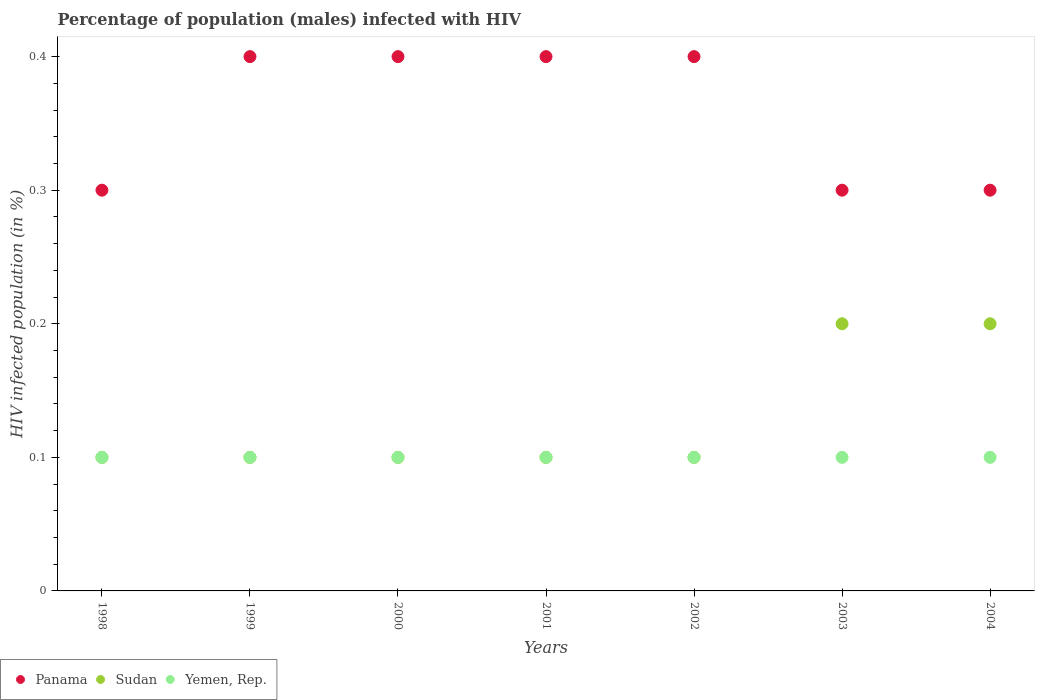How many different coloured dotlines are there?
Provide a short and direct response. 3. What is the percentage of HIV infected male population in Sudan in 2004?
Ensure brevity in your answer.  0.2. Across all years, what is the minimum percentage of HIV infected male population in Panama?
Give a very brief answer. 0.3. In which year was the percentage of HIV infected male population in Yemen, Rep. minimum?
Ensure brevity in your answer.  1998. What is the total percentage of HIV infected male population in Sudan in the graph?
Keep it short and to the point. 0.9. What is the difference between the percentage of HIV infected male population in Yemen, Rep. in 1998 and that in 2001?
Provide a succinct answer. 0. What is the difference between the percentage of HIV infected male population in Panama in 2004 and the percentage of HIV infected male population in Sudan in 1999?
Your answer should be very brief. 0.2. What is the average percentage of HIV infected male population in Yemen, Rep. per year?
Offer a terse response. 0.1. In the year 2003, what is the difference between the percentage of HIV infected male population in Panama and percentage of HIV infected male population in Yemen, Rep.?
Give a very brief answer. 0.2. What is the ratio of the percentage of HIV infected male population in Yemen, Rep. in 1998 to that in 2000?
Your response must be concise. 1. Is the difference between the percentage of HIV infected male population in Panama in 2001 and 2004 greater than the difference between the percentage of HIV infected male population in Yemen, Rep. in 2001 and 2004?
Keep it short and to the point. Yes. What is the difference between the highest and the lowest percentage of HIV infected male population in Yemen, Rep.?
Keep it short and to the point. 0. In how many years, is the percentage of HIV infected male population in Panama greater than the average percentage of HIV infected male population in Panama taken over all years?
Make the answer very short. 4. Is it the case that in every year, the sum of the percentage of HIV infected male population in Panama and percentage of HIV infected male population in Sudan  is greater than the percentage of HIV infected male population in Yemen, Rep.?
Make the answer very short. Yes. Does the percentage of HIV infected male population in Panama monotonically increase over the years?
Your answer should be compact. No. Is the percentage of HIV infected male population in Yemen, Rep. strictly greater than the percentage of HIV infected male population in Sudan over the years?
Your answer should be compact. No. Is the percentage of HIV infected male population in Yemen, Rep. strictly less than the percentage of HIV infected male population in Sudan over the years?
Provide a short and direct response. No. Does the graph contain any zero values?
Give a very brief answer. No. Does the graph contain grids?
Provide a short and direct response. No. Where does the legend appear in the graph?
Your answer should be compact. Bottom left. What is the title of the graph?
Ensure brevity in your answer.  Percentage of population (males) infected with HIV. What is the label or title of the X-axis?
Your answer should be very brief. Years. What is the label or title of the Y-axis?
Provide a short and direct response. HIV infected population (in %). What is the HIV infected population (in %) of Sudan in 1998?
Your answer should be compact. 0.1. What is the HIV infected population (in %) in Yemen, Rep. in 1998?
Your answer should be compact. 0.1. What is the HIV infected population (in %) in Panama in 1999?
Make the answer very short. 0.4. What is the HIV infected population (in %) in Panama in 2000?
Give a very brief answer. 0.4. What is the HIV infected population (in %) of Panama in 2001?
Provide a short and direct response. 0.4. What is the HIV infected population (in %) in Yemen, Rep. in 2001?
Ensure brevity in your answer.  0.1. What is the HIV infected population (in %) of Panama in 2002?
Offer a terse response. 0.4. What is the HIV infected population (in %) in Yemen, Rep. in 2002?
Keep it short and to the point. 0.1. What is the HIV infected population (in %) in Panama in 2003?
Provide a succinct answer. 0.3. Across all years, what is the maximum HIV infected population (in %) in Sudan?
Make the answer very short. 0.2. What is the difference between the HIV infected population (in %) of Panama in 1998 and that in 1999?
Provide a succinct answer. -0.1. What is the difference between the HIV infected population (in %) of Sudan in 1998 and that in 2000?
Your answer should be very brief. 0. What is the difference between the HIV infected population (in %) of Panama in 1998 and that in 2001?
Your response must be concise. -0.1. What is the difference between the HIV infected population (in %) of Yemen, Rep. in 1998 and that in 2001?
Provide a short and direct response. 0. What is the difference between the HIV infected population (in %) in Yemen, Rep. in 1998 and that in 2003?
Offer a terse response. 0. What is the difference between the HIV infected population (in %) of Panama in 1998 and that in 2004?
Give a very brief answer. 0. What is the difference between the HIV infected population (in %) of Sudan in 1998 and that in 2004?
Your answer should be very brief. -0.1. What is the difference between the HIV infected population (in %) in Panama in 1999 and that in 2000?
Keep it short and to the point. 0. What is the difference between the HIV infected population (in %) of Yemen, Rep. in 1999 and that in 2001?
Provide a short and direct response. 0. What is the difference between the HIV infected population (in %) of Panama in 1999 and that in 2002?
Give a very brief answer. 0. What is the difference between the HIV infected population (in %) in Sudan in 1999 and that in 2002?
Your response must be concise. 0. What is the difference between the HIV infected population (in %) in Yemen, Rep. in 1999 and that in 2002?
Make the answer very short. 0. What is the difference between the HIV infected population (in %) in Panama in 1999 and that in 2003?
Keep it short and to the point. 0.1. What is the difference between the HIV infected population (in %) of Sudan in 1999 and that in 2004?
Your answer should be very brief. -0.1. What is the difference between the HIV infected population (in %) of Sudan in 2000 and that in 2003?
Your response must be concise. -0.1. What is the difference between the HIV infected population (in %) of Yemen, Rep. in 2000 and that in 2003?
Provide a short and direct response. 0. What is the difference between the HIV infected population (in %) in Yemen, Rep. in 2001 and that in 2002?
Make the answer very short. 0. What is the difference between the HIV infected population (in %) of Yemen, Rep. in 2001 and that in 2003?
Keep it short and to the point. 0. What is the difference between the HIV infected population (in %) in Panama in 2001 and that in 2004?
Offer a very short reply. 0.1. What is the difference between the HIV infected population (in %) in Yemen, Rep. in 2001 and that in 2004?
Offer a very short reply. 0. What is the difference between the HIV infected population (in %) in Panama in 2002 and that in 2003?
Provide a succinct answer. 0.1. What is the difference between the HIV infected population (in %) of Sudan in 2002 and that in 2003?
Ensure brevity in your answer.  -0.1. What is the difference between the HIV infected population (in %) in Sudan in 2002 and that in 2004?
Keep it short and to the point. -0.1. What is the difference between the HIV infected population (in %) of Yemen, Rep. in 2002 and that in 2004?
Keep it short and to the point. 0. What is the difference between the HIV infected population (in %) in Panama in 2003 and that in 2004?
Provide a short and direct response. 0. What is the difference between the HIV infected population (in %) of Sudan in 2003 and that in 2004?
Offer a very short reply. 0. What is the difference between the HIV infected population (in %) of Yemen, Rep. in 2003 and that in 2004?
Offer a very short reply. 0. What is the difference between the HIV infected population (in %) in Sudan in 1998 and the HIV infected population (in %) in Yemen, Rep. in 1999?
Make the answer very short. 0. What is the difference between the HIV infected population (in %) of Panama in 1998 and the HIV infected population (in %) of Sudan in 2000?
Offer a very short reply. 0.2. What is the difference between the HIV infected population (in %) of Panama in 1998 and the HIV infected population (in %) of Sudan in 2001?
Ensure brevity in your answer.  0.2. What is the difference between the HIV infected population (in %) of Panama in 1998 and the HIV infected population (in %) of Yemen, Rep. in 2001?
Give a very brief answer. 0.2. What is the difference between the HIV infected population (in %) in Sudan in 1998 and the HIV infected population (in %) in Yemen, Rep. in 2001?
Offer a very short reply. 0. What is the difference between the HIV infected population (in %) in Panama in 1998 and the HIV infected population (in %) in Sudan in 2002?
Offer a very short reply. 0.2. What is the difference between the HIV infected population (in %) in Sudan in 1998 and the HIV infected population (in %) in Yemen, Rep. in 2002?
Ensure brevity in your answer.  0. What is the difference between the HIV infected population (in %) in Panama in 1998 and the HIV infected population (in %) in Sudan in 2003?
Ensure brevity in your answer.  0.1. What is the difference between the HIV infected population (in %) of Panama in 1998 and the HIV infected population (in %) of Yemen, Rep. in 2003?
Give a very brief answer. 0.2. What is the difference between the HIV infected population (in %) in Sudan in 1998 and the HIV infected population (in %) in Yemen, Rep. in 2003?
Provide a short and direct response. 0. What is the difference between the HIV infected population (in %) in Panama in 1998 and the HIV infected population (in %) in Sudan in 2004?
Give a very brief answer. 0.1. What is the difference between the HIV infected population (in %) in Sudan in 1998 and the HIV infected population (in %) in Yemen, Rep. in 2004?
Your response must be concise. 0. What is the difference between the HIV infected population (in %) in Sudan in 1999 and the HIV infected population (in %) in Yemen, Rep. in 2000?
Offer a terse response. 0. What is the difference between the HIV infected population (in %) in Panama in 1999 and the HIV infected population (in %) in Sudan in 2001?
Offer a very short reply. 0.3. What is the difference between the HIV infected population (in %) in Sudan in 1999 and the HIV infected population (in %) in Yemen, Rep. in 2002?
Offer a terse response. 0. What is the difference between the HIV infected population (in %) of Panama in 1999 and the HIV infected population (in %) of Yemen, Rep. in 2003?
Keep it short and to the point. 0.3. What is the difference between the HIV infected population (in %) of Panama in 1999 and the HIV infected population (in %) of Yemen, Rep. in 2004?
Offer a terse response. 0.3. What is the difference between the HIV infected population (in %) of Sudan in 1999 and the HIV infected population (in %) of Yemen, Rep. in 2004?
Make the answer very short. 0. What is the difference between the HIV infected population (in %) in Panama in 2000 and the HIV infected population (in %) in Yemen, Rep. in 2001?
Provide a short and direct response. 0.3. What is the difference between the HIV infected population (in %) of Panama in 2000 and the HIV infected population (in %) of Yemen, Rep. in 2002?
Give a very brief answer. 0.3. What is the difference between the HIV infected population (in %) in Sudan in 2000 and the HIV infected population (in %) in Yemen, Rep. in 2002?
Your response must be concise. 0. What is the difference between the HIV infected population (in %) of Panama in 2000 and the HIV infected population (in %) of Yemen, Rep. in 2003?
Your answer should be compact. 0.3. What is the difference between the HIV infected population (in %) in Sudan in 2000 and the HIV infected population (in %) in Yemen, Rep. in 2003?
Offer a very short reply. 0. What is the difference between the HIV infected population (in %) of Panama in 2000 and the HIV infected population (in %) of Sudan in 2004?
Your answer should be very brief. 0.2. What is the difference between the HIV infected population (in %) of Panama in 2000 and the HIV infected population (in %) of Yemen, Rep. in 2004?
Provide a succinct answer. 0.3. What is the difference between the HIV infected population (in %) in Sudan in 2000 and the HIV infected population (in %) in Yemen, Rep. in 2004?
Keep it short and to the point. 0. What is the difference between the HIV infected population (in %) in Panama in 2001 and the HIV infected population (in %) in Sudan in 2002?
Your response must be concise. 0.3. What is the difference between the HIV infected population (in %) in Panama in 2001 and the HIV infected population (in %) in Yemen, Rep. in 2002?
Ensure brevity in your answer.  0.3. What is the difference between the HIV infected population (in %) of Panama in 2001 and the HIV infected population (in %) of Sudan in 2003?
Your answer should be compact. 0.2. What is the difference between the HIV infected population (in %) in Panama in 2001 and the HIV infected population (in %) in Yemen, Rep. in 2003?
Provide a succinct answer. 0.3. What is the difference between the HIV infected population (in %) in Panama in 2001 and the HIV infected population (in %) in Yemen, Rep. in 2004?
Offer a very short reply. 0.3. What is the difference between the HIV infected population (in %) in Panama in 2002 and the HIV infected population (in %) in Sudan in 2003?
Offer a very short reply. 0.2. What is the difference between the HIV infected population (in %) of Panama in 2002 and the HIV infected population (in %) of Yemen, Rep. in 2003?
Offer a very short reply. 0.3. What is the difference between the HIV infected population (in %) of Sudan in 2002 and the HIV infected population (in %) of Yemen, Rep. in 2004?
Give a very brief answer. 0. What is the difference between the HIV infected population (in %) of Panama in 2003 and the HIV infected population (in %) of Yemen, Rep. in 2004?
Give a very brief answer. 0.2. What is the average HIV infected population (in %) in Panama per year?
Your answer should be compact. 0.36. What is the average HIV infected population (in %) in Sudan per year?
Your response must be concise. 0.13. What is the average HIV infected population (in %) in Yemen, Rep. per year?
Provide a succinct answer. 0.1. In the year 1998, what is the difference between the HIV infected population (in %) in Panama and HIV infected population (in %) in Yemen, Rep.?
Your answer should be very brief. 0.2. In the year 1998, what is the difference between the HIV infected population (in %) of Sudan and HIV infected population (in %) of Yemen, Rep.?
Provide a short and direct response. 0. In the year 1999, what is the difference between the HIV infected population (in %) in Sudan and HIV infected population (in %) in Yemen, Rep.?
Provide a short and direct response. 0. In the year 2000, what is the difference between the HIV infected population (in %) in Panama and HIV infected population (in %) in Sudan?
Make the answer very short. 0.3. In the year 2000, what is the difference between the HIV infected population (in %) in Panama and HIV infected population (in %) in Yemen, Rep.?
Your response must be concise. 0.3. In the year 2001, what is the difference between the HIV infected population (in %) in Panama and HIV infected population (in %) in Sudan?
Your response must be concise. 0.3. In the year 2001, what is the difference between the HIV infected population (in %) of Sudan and HIV infected population (in %) of Yemen, Rep.?
Provide a succinct answer. 0. In the year 2002, what is the difference between the HIV infected population (in %) in Panama and HIV infected population (in %) in Sudan?
Provide a short and direct response. 0.3. What is the ratio of the HIV infected population (in %) in Panama in 1998 to that in 1999?
Your response must be concise. 0.75. What is the ratio of the HIV infected population (in %) in Sudan in 1998 to that in 1999?
Provide a succinct answer. 1. What is the ratio of the HIV infected population (in %) in Panama in 1998 to that in 2000?
Provide a succinct answer. 0.75. What is the ratio of the HIV infected population (in %) in Sudan in 1998 to that in 2000?
Make the answer very short. 1. What is the ratio of the HIV infected population (in %) of Yemen, Rep. in 1998 to that in 2000?
Keep it short and to the point. 1. What is the ratio of the HIV infected population (in %) in Panama in 1998 to that in 2001?
Keep it short and to the point. 0.75. What is the ratio of the HIV infected population (in %) in Sudan in 1998 to that in 2001?
Make the answer very short. 1. What is the ratio of the HIV infected population (in %) of Yemen, Rep. in 1998 to that in 2001?
Your answer should be compact. 1. What is the ratio of the HIV infected population (in %) of Sudan in 1998 to that in 2002?
Offer a terse response. 1. What is the ratio of the HIV infected population (in %) of Yemen, Rep. in 1998 to that in 2002?
Your answer should be very brief. 1. What is the ratio of the HIV infected population (in %) of Yemen, Rep. in 1998 to that in 2003?
Your answer should be very brief. 1. What is the ratio of the HIV infected population (in %) of Panama in 1998 to that in 2004?
Your answer should be compact. 1. What is the ratio of the HIV infected population (in %) in Sudan in 1998 to that in 2004?
Ensure brevity in your answer.  0.5. What is the ratio of the HIV infected population (in %) of Yemen, Rep. in 1998 to that in 2004?
Offer a very short reply. 1. What is the ratio of the HIV infected population (in %) of Sudan in 1999 to that in 2000?
Give a very brief answer. 1. What is the ratio of the HIV infected population (in %) in Yemen, Rep. in 1999 to that in 2000?
Your response must be concise. 1. What is the ratio of the HIV infected population (in %) of Panama in 1999 to that in 2001?
Your response must be concise. 1. What is the ratio of the HIV infected population (in %) in Sudan in 1999 to that in 2002?
Your answer should be very brief. 1. What is the ratio of the HIV infected population (in %) in Panama in 1999 to that in 2003?
Your answer should be compact. 1.33. What is the ratio of the HIV infected population (in %) of Yemen, Rep. in 1999 to that in 2003?
Provide a succinct answer. 1. What is the ratio of the HIV infected population (in %) in Sudan in 1999 to that in 2004?
Offer a very short reply. 0.5. What is the ratio of the HIV infected population (in %) in Yemen, Rep. in 1999 to that in 2004?
Give a very brief answer. 1. What is the ratio of the HIV infected population (in %) in Yemen, Rep. in 2000 to that in 2001?
Your answer should be compact. 1. What is the ratio of the HIV infected population (in %) in Sudan in 2000 to that in 2002?
Give a very brief answer. 1. What is the ratio of the HIV infected population (in %) of Panama in 2000 to that in 2003?
Keep it short and to the point. 1.33. What is the ratio of the HIV infected population (in %) of Sudan in 2000 to that in 2003?
Keep it short and to the point. 0.5. What is the ratio of the HIV infected population (in %) of Panama in 2000 to that in 2004?
Your answer should be compact. 1.33. What is the ratio of the HIV infected population (in %) of Yemen, Rep. in 2001 to that in 2002?
Give a very brief answer. 1. What is the ratio of the HIV infected population (in %) in Panama in 2001 to that in 2003?
Offer a very short reply. 1.33. What is the ratio of the HIV infected population (in %) of Panama in 2001 to that in 2004?
Your answer should be compact. 1.33. What is the ratio of the HIV infected population (in %) in Sudan in 2001 to that in 2004?
Provide a succinct answer. 0.5. What is the ratio of the HIV infected population (in %) in Yemen, Rep. in 2001 to that in 2004?
Offer a terse response. 1. What is the ratio of the HIV infected population (in %) in Yemen, Rep. in 2002 to that in 2004?
Provide a succinct answer. 1. What is the ratio of the HIV infected population (in %) of Sudan in 2003 to that in 2004?
Offer a very short reply. 1. What is the ratio of the HIV infected population (in %) of Yemen, Rep. in 2003 to that in 2004?
Ensure brevity in your answer.  1. What is the difference between the highest and the second highest HIV infected population (in %) of Panama?
Give a very brief answer. 0. What is the difference between the highest and the second highest HIV infected population (in %) of Sudan?
Give a very brief answer. 0. What is the difference between the highest and the second highest HIV infected population (in %) of Yemen, Rep.?
Keep it short and to the point. 0. What is the difference between the highest and the lowest HIV infected population (in %) in Panama?
Give a very brief answer. 0.1. What is the difference between the highest and the lowest HIV infected population (in %) in Sudan?
Your answer should be very brief. 0.1. 